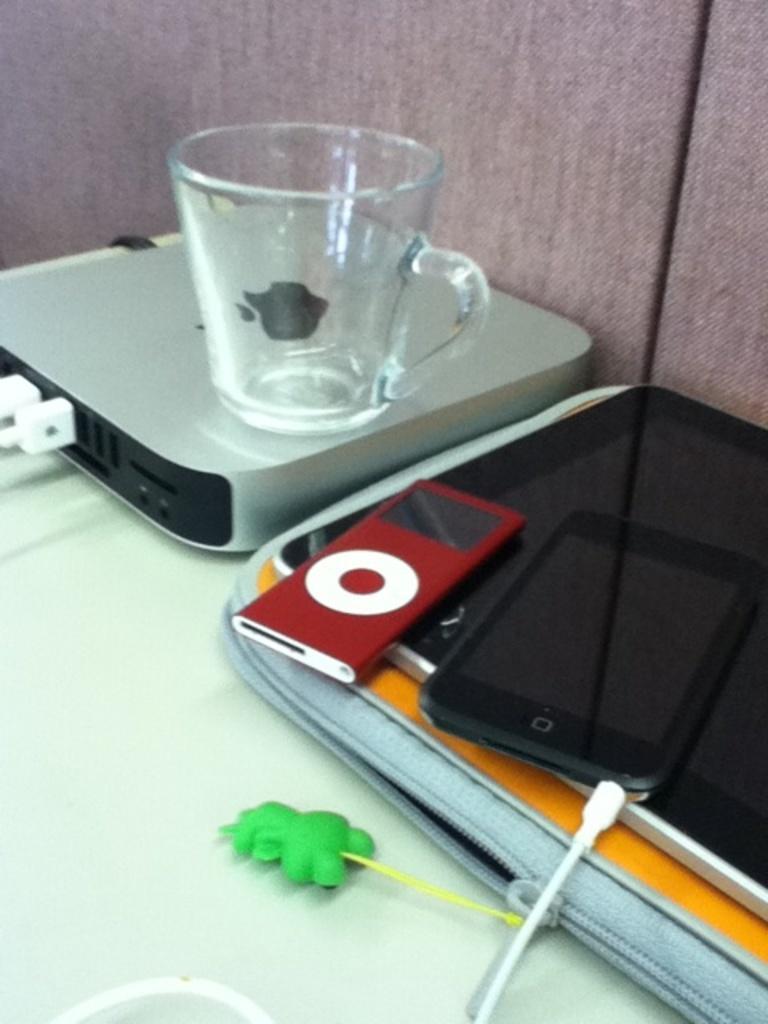Please provide a concise description of this image. This image consists of a apple box and a table on which there are a mobile, bag, key chain, and a mug. In the background, there is a pink wall. 